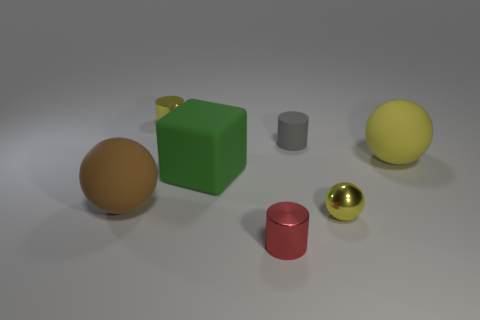What shape is the rubber thing that is the same color as the metal sphere?
Make the answer very short. Sphere. What is the size of the matte sphere that is the same color as the small shiny sphere?
Your answer should be compact. Large. There is another rubber object that is the same shape as the large brown object; what is its size?
Provide a succinct answer. Large. Is there any other thing that has the same material as the large yellow sphere?
Provide a short and direct response. Yes. There is a metallic cylinder behind the big yellow matte object; is its size the same as the sphere behind the large rubber cube?
Give a very brief answer. No. How many small objects are cubes or gray cylinders?
Make the answer very short. 1. What number of objects are in front of the large yellow matte ball and left of the tiny red metallic cylinder?
Provide a short and direct response. 2. Are the red object and the large object that is behind the big green object made of the same material?
Keep it short and to the point. No. What number of purple things are either matte blocks or large spheres?
Make the answer very short. 0. Is there a green matte block that has the same size as the yellow shiny ball?
Your response must be concise. No. 